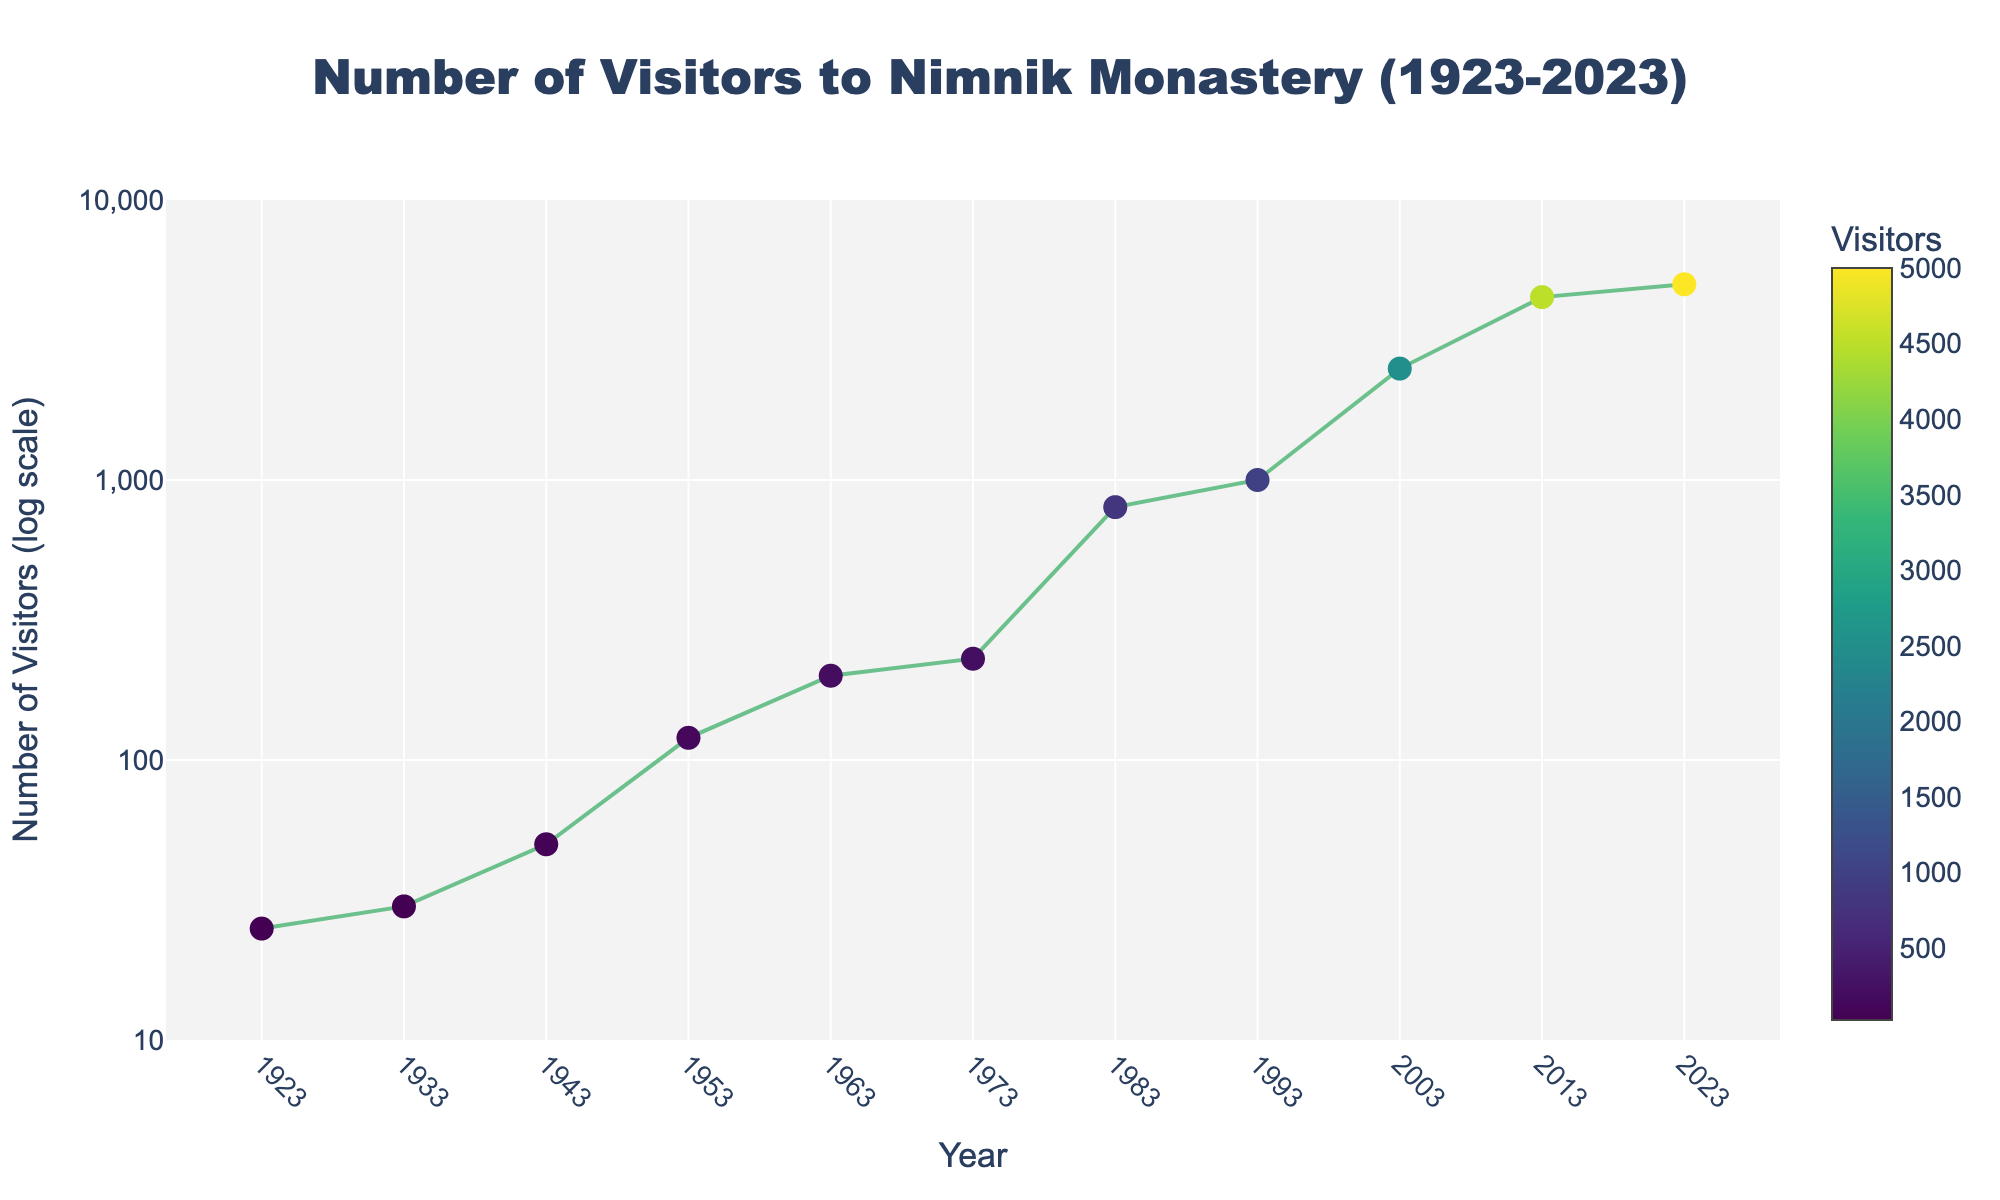What is the title of the figure? The title of the figure is displayed at the top of the chart in large bold font.
Answer: Number of Visitors to Nimnik Monastery (1923-2023) How many data points are plotted on the figure? The data points can be identified by counting the markers on the plot.
Answer: 11 Which year had the highest number of visitors, and what was that number? The highest number of visitors is represented by the marker at the y-axis peak. This corresponds to the year 2023.
Answer: 2023, 5000 Is there a year where the number of visitors exceeds 1000 for the first time? The first data point above 1000 is the year where the number of visitors exceeds 1000.
Answer: 1983 By how much did the number of visitors increase from 1953 to 1963? Subtract the number of visitors in 1953 from the number in 1963 (200 - 120).
Answer: 80 Which decade saw the largest growth in the number of visitors? Calculate the difference in the number of visitors across each decade and identify the maximum increase. The decade with an increase from 800 to 1000 (1983 to 1993) represents the largest growth.
Answer: 1983-1993 What is the number of visitors in 1943? Locate the data point corresponding to the year 1943 on the x-axis and identify the y-axis value.
Answer: 50 How does the number of visitors change between 2003 and 2013? Compare the number of visitors in 2003 and 2013 by finding the difference (4500 - 2500).
Answer: Increase by 2000 Which year marks the transition where the number of visitors went from hundreds to thousands? Find the first year where the y-axis value changes from hundreds to thousands.
Answer: 1983 What can you say about the trend in the number of visitors from 1923 to 2023? Observing the log-scale y-axis, the overall trend shows an exponential increase in visitors over the century.
Answer: Exponential increase 